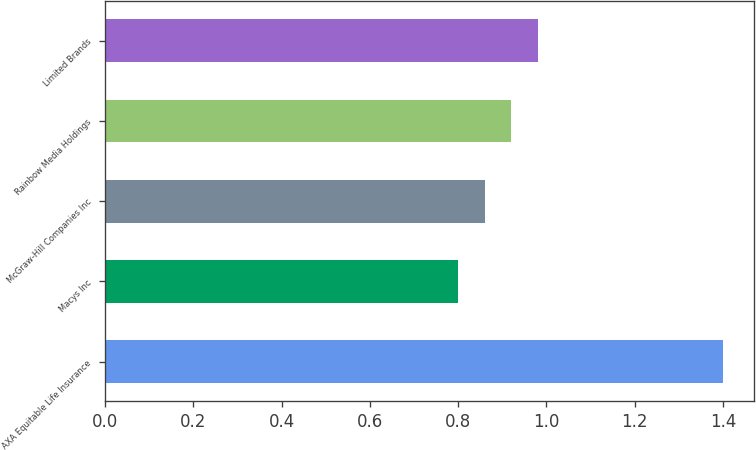Convert chart. <chart><loc_0><loc_0><loc_500><loc_500><bar_chart><fcel>AXA Equitable Life Insurance<fcel>Macys Inc<fcel>McGraw-Hill Companies Inc<fcel>Rainbow Media Holdings<fcel>Limited Brands<nl><fcel>1.4<fcel>0.8<fcel>0.86<fcel>0.92<fcel>0.98<nl></chart> 